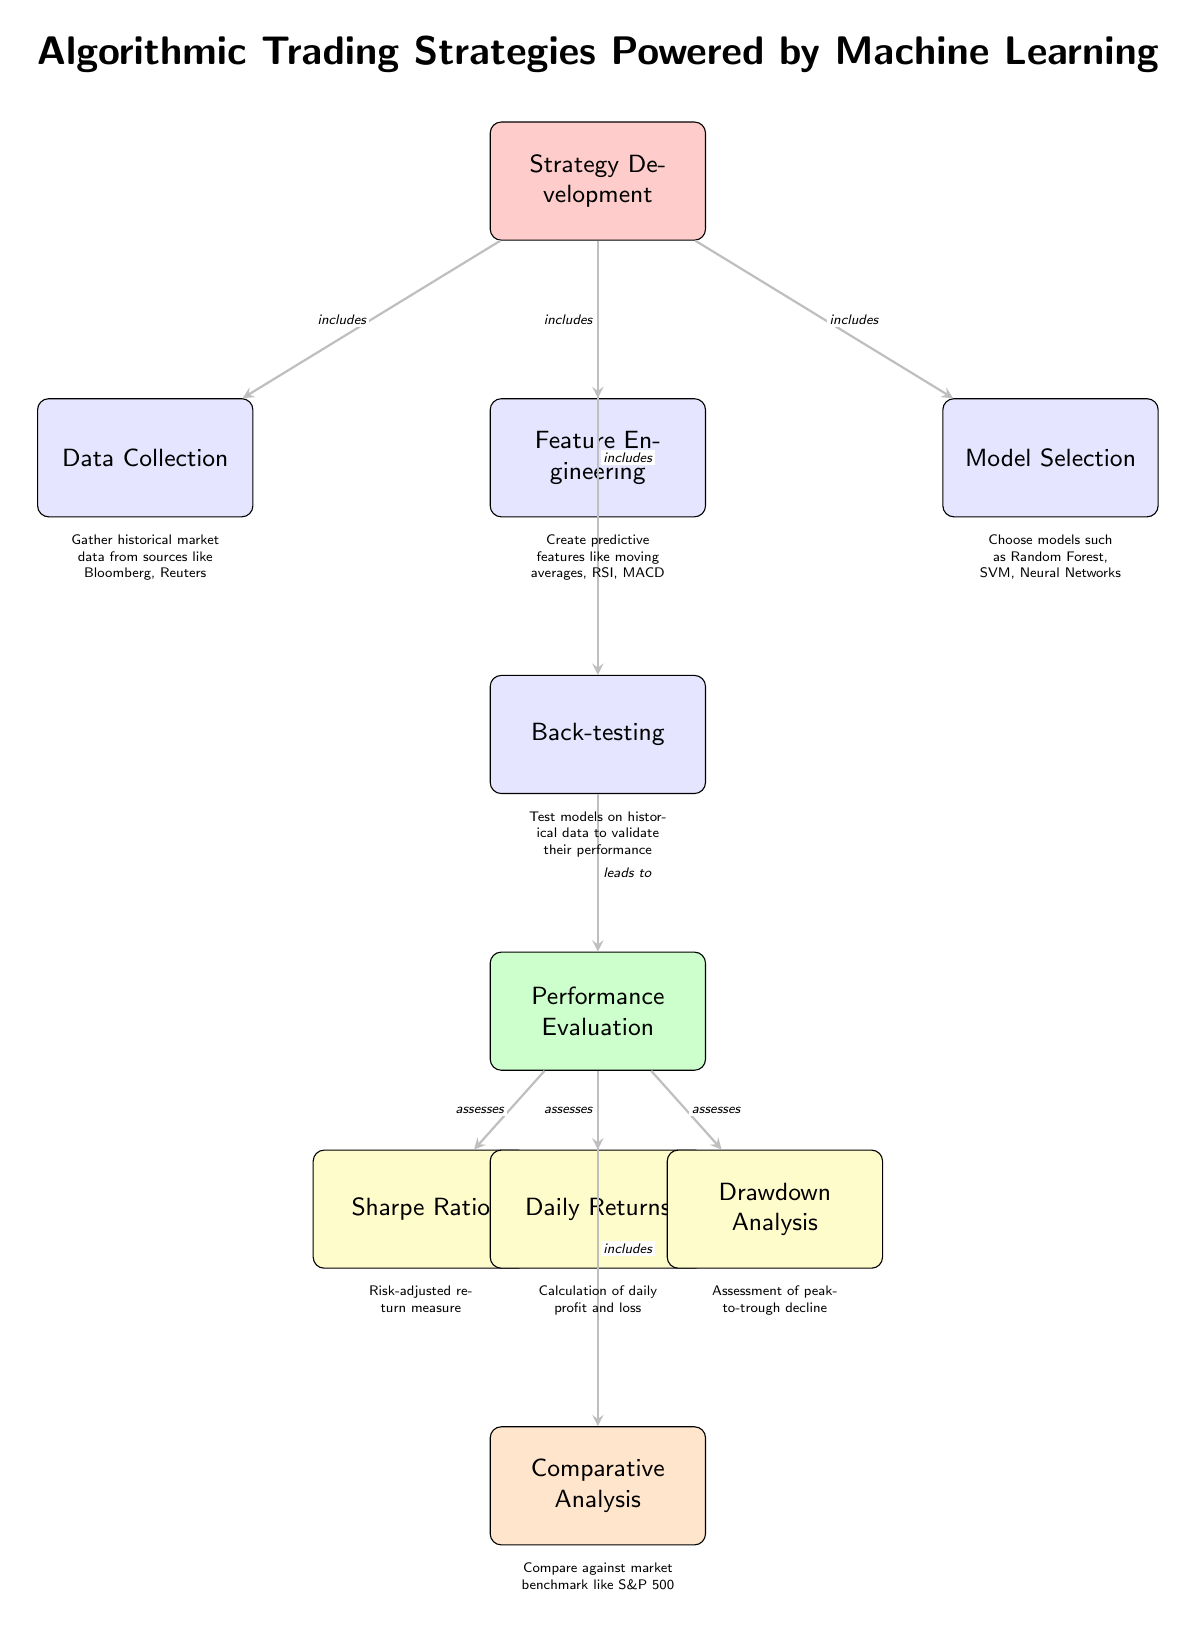What is the first phase in the algorithmic trading strategy development? The first phase is labeled as "Strategy Development" at the top of the diagram, which includes initial steps like data collection, feature engineering, and others below it.
Answer: Strategy Development How many performance metrics are evaluated in the diagram? There are three specific performance metrics listed: Sharpe Ratio, Daily Returns, and Drawdown Analysis, all connected to the Performance Evaluation node.
Answer: Three What process follows "Back-testing" in the diagram? The arrow from the Back-testing node leads directly to the Performance Evaluation node, indicating that performance evaluation follows back-testing.
Answer: Performance Evaluation What does the Sharpe Ratio assess? The diagram indicates that the Sharpe Ratio is assessed as part of the Performance Evaluation phase, focusing on risk-adjusted returns in algorithmic trading.
Answer: Risk-adjusted return measure Which models are chosen during the strategy development phase? The diagram lists "Random Forest", "SVM", and "Neural Networks" as the models selected under the Model Selection node.
Answer: Random Forest, SVM, Neural Networks What is the purpose of "Data Collection"? In the diagram, the description below the Data Collection node states it involves gathering historical market data from sources like Bloomberg and Reuters.
Answer: Gather historical market data How does Drawdown Analysis relate to Performance Evaluation? Drawdown Analysis is connected to the Performance Evaluation node, indicating that it is one of the assessments made during performance evaluation of the trading strategies.
Answer: Assesses performance Which section directly includes Comparative Analysis? Comparative Analysis is a sub-node directly below the Performance Evaluation node, indicating that it includes the comparison against a market benchmark.
Answer: Performance Evaluation 